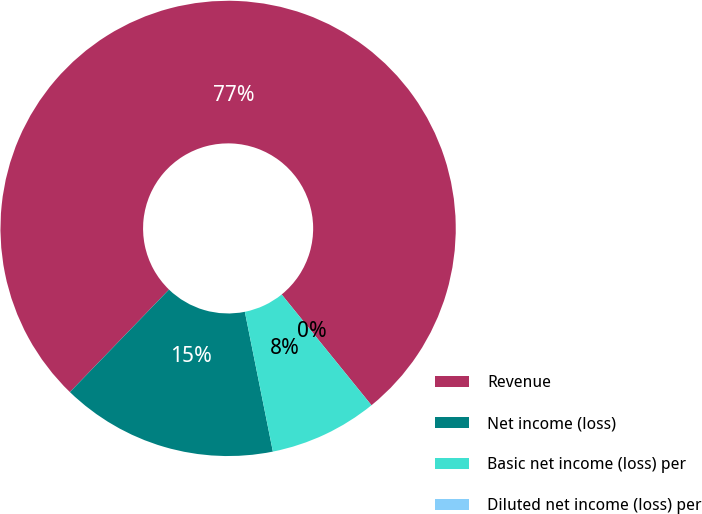Convert chart. <chart><loc_0><loc_0><loc_500><loc_500><pie_chart><fcel>Revenue<fcel>Net income (loss)<fcel>Basic net income (loss) per<fcel>Diluted net income (loss) per<nl><fcel>76.92%<fcel>15.38%<fcel>7.69%<fcel>0.0%<nl></chart> 